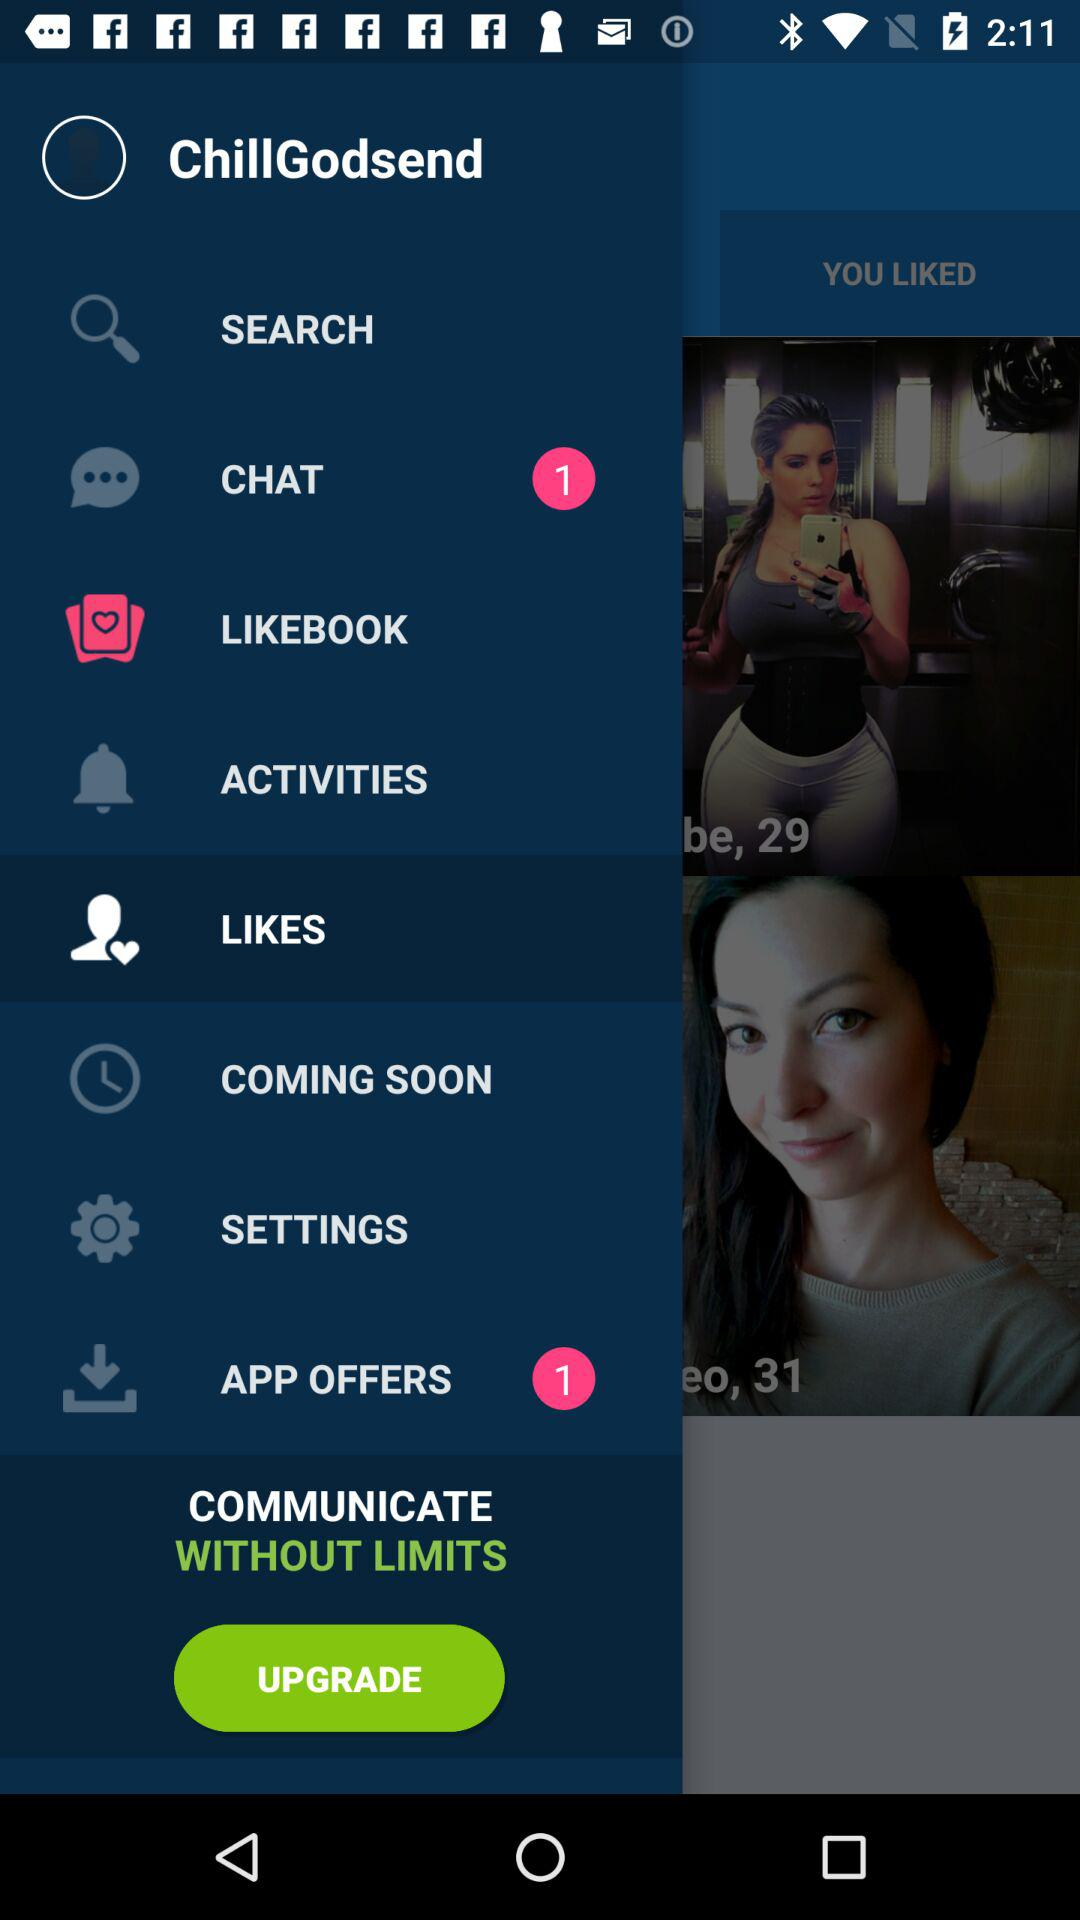How many unread chats are there? There is 1 unread chat. 